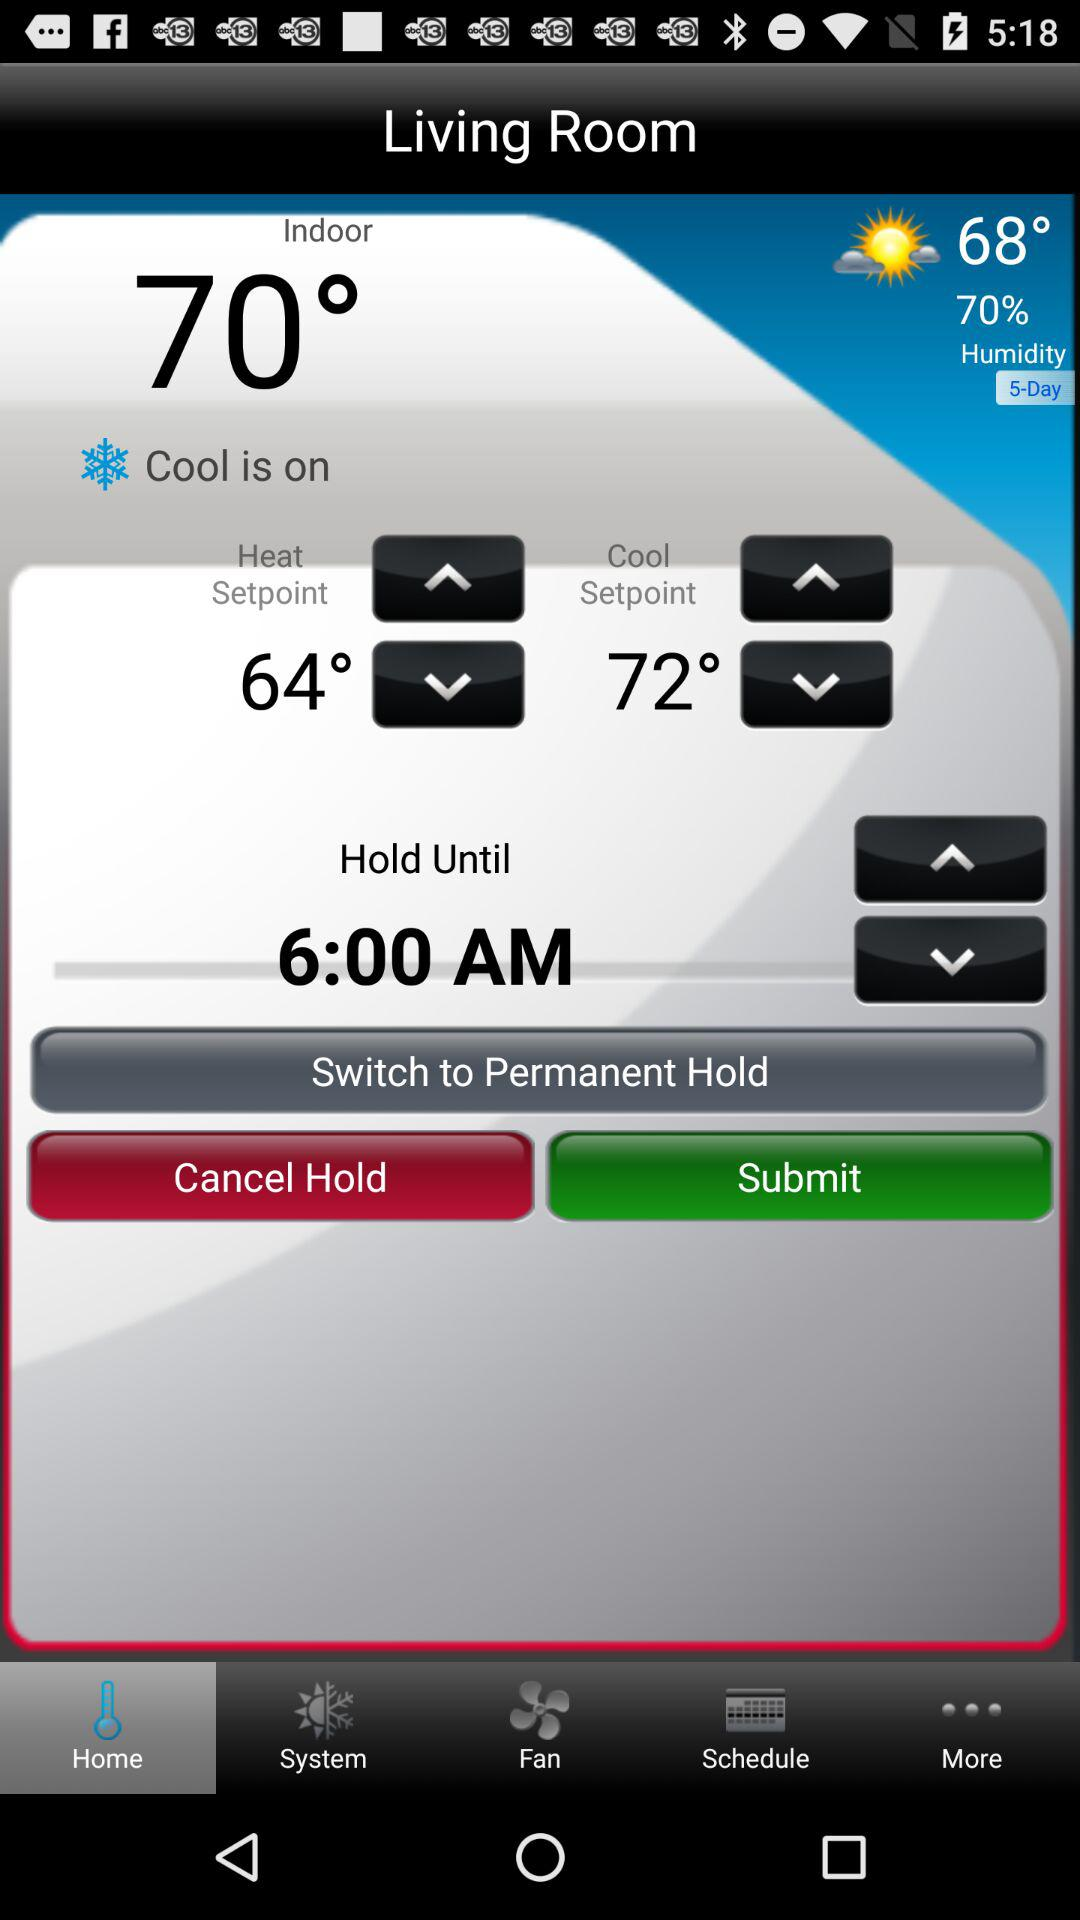What is the "Cool Setpoint"? The "Cool Setpoint" is 72°. 